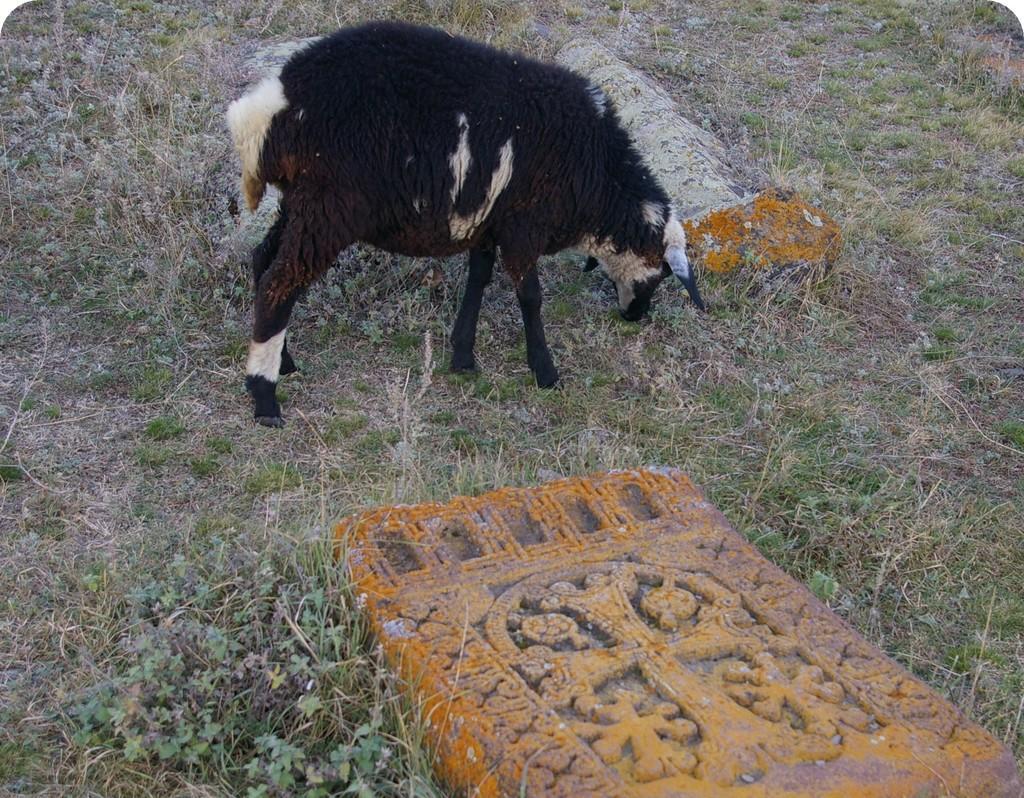Please provide a concise description of this image. In this image we can see an animal and also the graves. In the background we can see the grass. 